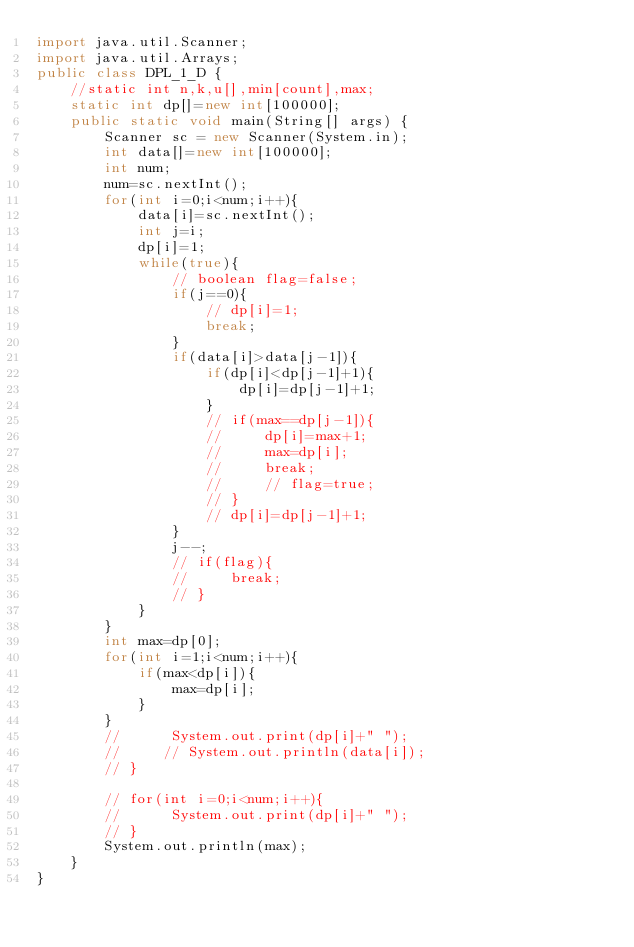<code> <loc_0><loc_0><loc_500><loc_500><_Java_>import java.util.Scanner;
import java.util.Arrays;
public class DPL_1_D {
	//static int n,k,u[],min[count],max;
    static int dp[]=new int[100000];
	public static void main(String[] args) {
		Scanner sc = new Scanner(System.in);
		int data[]=new int[100000];
		int num;
        num=sc.nextInt();
        for(int i=0;i<num;i++){
            data[i]=sc.nextInt();
            int j=i;
            dp[i]=1;
            while(true){
                // boolean flag=false;
                if(j==0){
                    // dp[i]=1;
                    break;
                }
                if(data[i]>data[j-1]){
                    if(dp[i]<dp[j-1]+1){
                        dp[i]=dp[j-1]+1;
                    }
                    // if(max==dp[j-1]){
                    //     dp[i]=max+1;
                    //     max=dp[i];
                    //     break;
                    //     // flag=true;
                    // }
                    // dp[i]=dp[j-1]+1;
                }
                j--;
                // if(flag){
                //     break;
                // }
            }
        }
        int max=dp[0];
        for(int i=1;i<num;i++){
            if(max<dp[i]){
                max=dp[i];
            }
        }
        //      System.out.print(dp[i]+" ");
        //     // System.out.println(data[i]);
        // }

        // for(int i=0;i<num;i++){
        //      System.out.print(dp[i]+" ");
        // }
        System.out.println(max);
    }
}</code> 